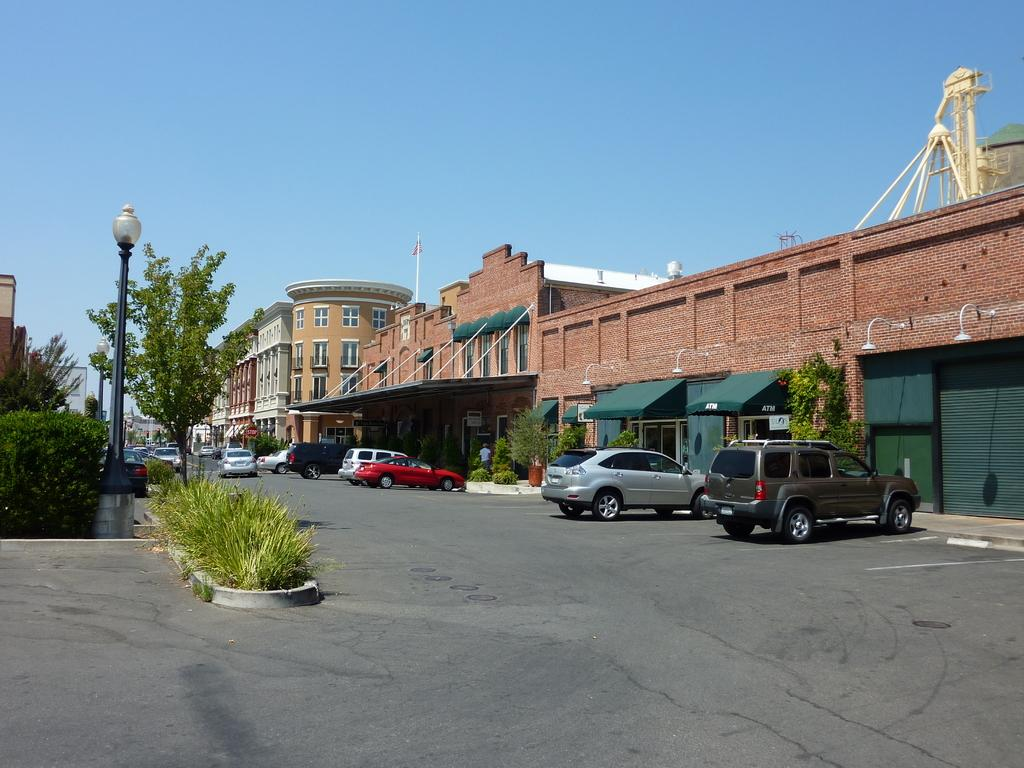What type of vehicles can be seen on the road in the image? There are cars on the road in the image. What natural elements are visible in the image? There are trees visible in the image. What type of man-made structure is present in the image? There is a street light in the image. What architectural features can be seen on the buildings in the image? The buildings have windows in the image. What is visible at the top of the image? The sky is visible at the top of the image. How many jellyfish can be seen swimming in the sky in the image? There are no jellyfish present in the image, and they cannot swim in the sky. What emotion is being expressed by the buildings in the image? Buildings do not express emotions; they are inanimate objects. 